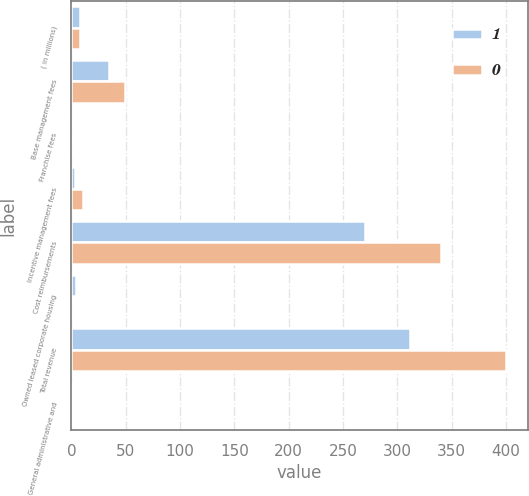Convert chart. <chart><loc_0><loc_0><loc_500><loc_500><stacked_bar_chart><ecel><fcel>( in millions)<fcel>Base management fees<fcel>Franchise fees<fcel>Incentive management fees<fcel>Cost reimbursements<fcel>Owned leased corporate housing<fcel>Total revenue<fcel>General administrative and<nl><fcel>1<fcel>7.5<fcel>35<fcel>0<fcel>3<fcel>270<fcel>4<fcel>312<fcel>1<nl><fcel>0<fcel>7.5<fcel>49<fcel>0<fcel>11<fcel>340<fcel>0<fcel>400<fcel>1<nl></chart> 